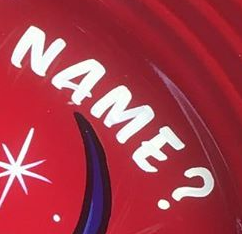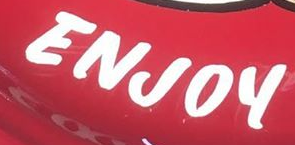What words can you see in these images in sequence, separated by a semicolon? NAME?; ENJOY 